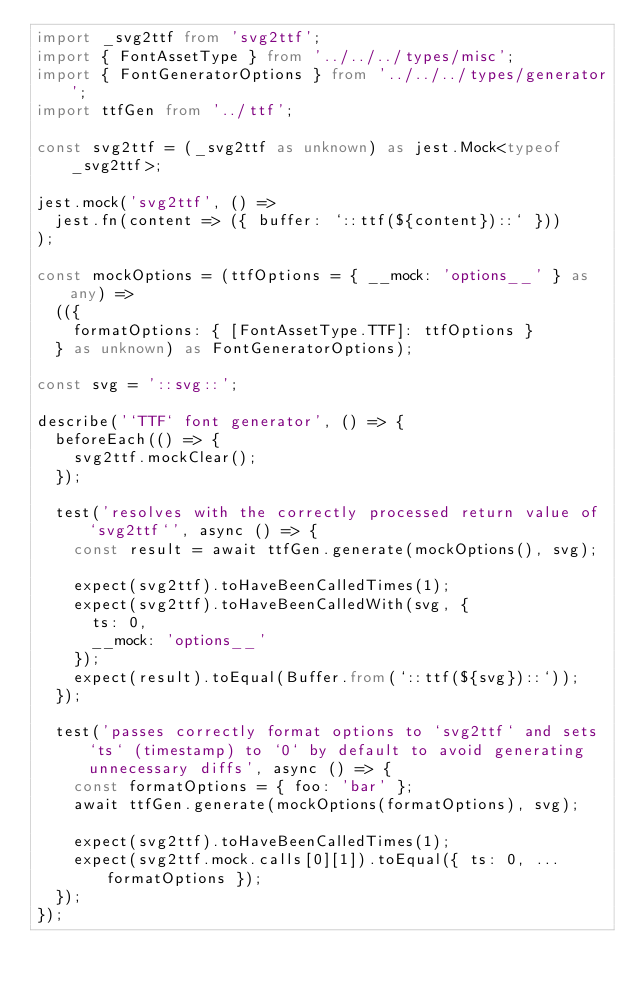Convert code to text. <code><loc_0><loc_0><loc_500><loc_500><_TypeScript_>import _svg2ttf from 'svg2ttf';
import { FontAssetType } from '../../../types/misc';
import { FontGeneratorOptions } from '../../../types/generator';
import ttfGen from '../ttf';

const svg2ttf = (_svg2ttf as unknown) as jest.Mock<typeof _svg2ttf>;

jest.mock('svg2ttf', () =>
  jest.fn(content => ({ buffer: `::ttf(${content})::` }))
);

const mockOptions = (ttfOptions = { __mock: 'options__' } as any) =>
  (({
    formatOptions: { [FontAssetType.TTF]: ttfOptions }
  } as unknown) as FontGeneratorOptions);

const svg = '::svg::';

describe('`TTF` font generator', () => {
  beforeEach(() => {
    svg2ttf.mockClear();
  });

  test('resolves with the correctly processed return value of `svg2ttf`', async () => {
    const result = await ttfGen.generate(mockOptions(), svg);

    expect(svg2ttf).toHaveBeenCalledTimes(1);
    expect(svg2ttf).toHaveBeenCalledWith(svg, {
      ts: 0,
      __mock: 'options__'
    });
    expect(result).toEqual(Buffer.from(`::ttf(${svg})::`));
  });

  test('passes correctly format options to `svg2ttf` and sets `ts` (timestamp) to `0` by default to avoid generating unnecessary diffs', async () => {
    const formatOptions = { foo: 'bar' };
    await ttfGen.generate(mockOptions(formatOptions), svg);

    expect(svg2ttf).toHaveBeenCalledTimes(1);
    expect(svg2ttf.mock.calls[0][1]).toEqual({ ts: 0, ...formatOptions });
  });
});
</code> 